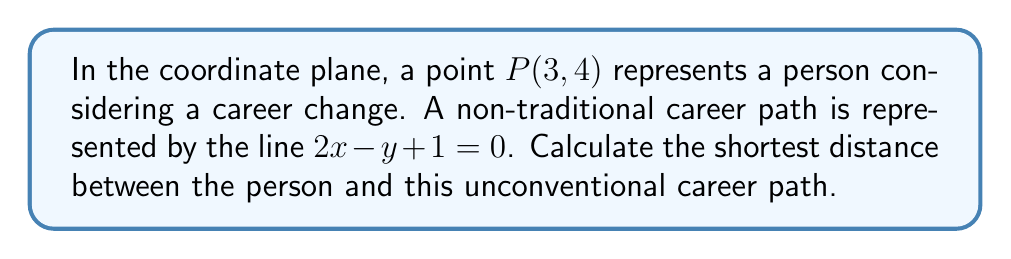Give your solution to this math problem. To find the shortest distance between a point and a line, we'll use the formula:

$$d = \frac{|ax_0 + by_0 + c|}{\sqrt{a^2 + b^2}}$$

Where $(x_0, y_0)$ is the point, and the line is in the form $ax + by + c = 0$.

Step 1: Identify the components
- Point P(3, 4): $x_0 = 3$, $y_0 = 4$
- Line $2x - y + 1 = 0$: $a = 2$, $b = -1$, $c = 1$

Step 2: Substitute into the formula
$$d = \frac{|2(3) + (-1)(4) + 1|}{\sqrt{2^2 + (-1)^2}}$$

Step 3: Simplify the numerator
$$d = \frac{|6 - 4 + 1|}{\sqrt{4 + 1}} = \frac{|3|}{\sqrt{5}}$$

Step 4: Simplify the fraction
$$d = \frac{3}{\sqrt{5}}$$

Step 5: Simplify the square root (optional)
$$d = \frac{3}{\sqrt{5}} = \frac{3\sqrt{5}}{5}$$

[asy]
import geometry;

unitsize(1cm);

pair P = (3,4);
real m = 0.5;
real b = -0.5;

draw((-1,-1)--(5,3), arrow=Arrow(TeXHead));
dot(P, red);
label("P(3,4)", P, NE, red);
label("Non-traditional career path", (5,3), E);

real x = (P.y - b + m*P.x) / (1 + m^2);
real y = m*x + b;

draw(P--(x,y), dashed);
dot((x,y));

label("Shortest distance", ((P.x+x)/2, (P.y+y)/2), NW);
[/asy]
Answer: $\frac{3\sqrt{5}}{5}$ 